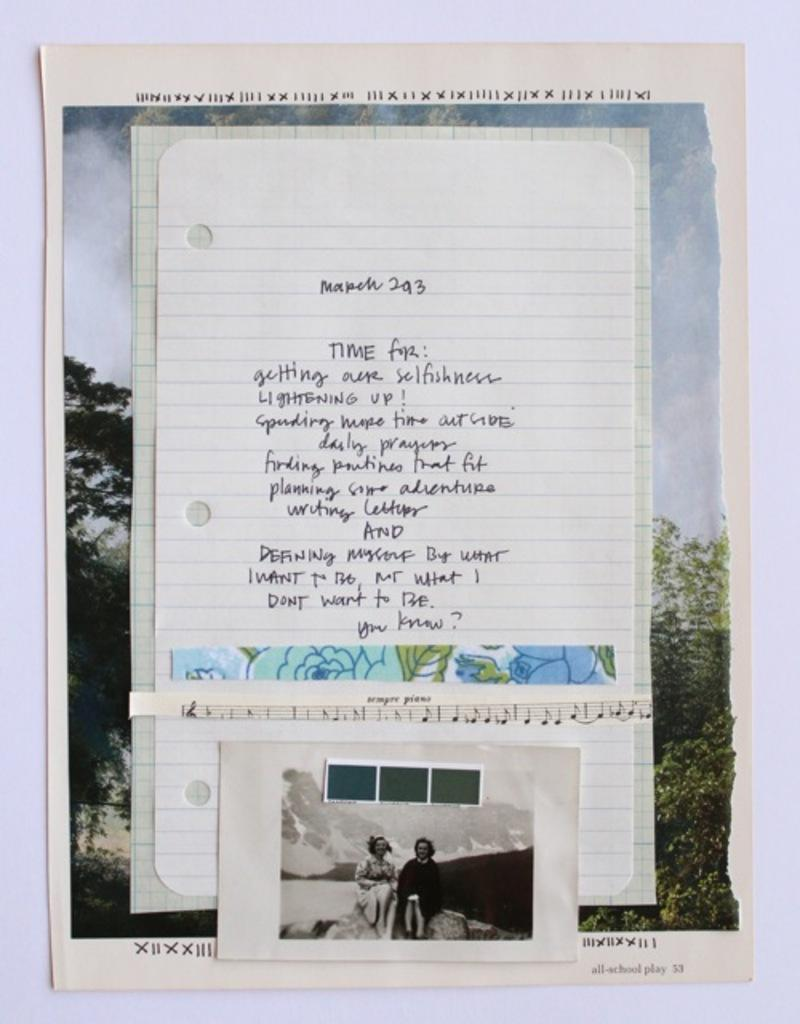Provide a one-sentence caption for the provided image. A notebook page where somebody wrote what they want to do, including lightening up, saying daily prayers, and planning some adventures. 